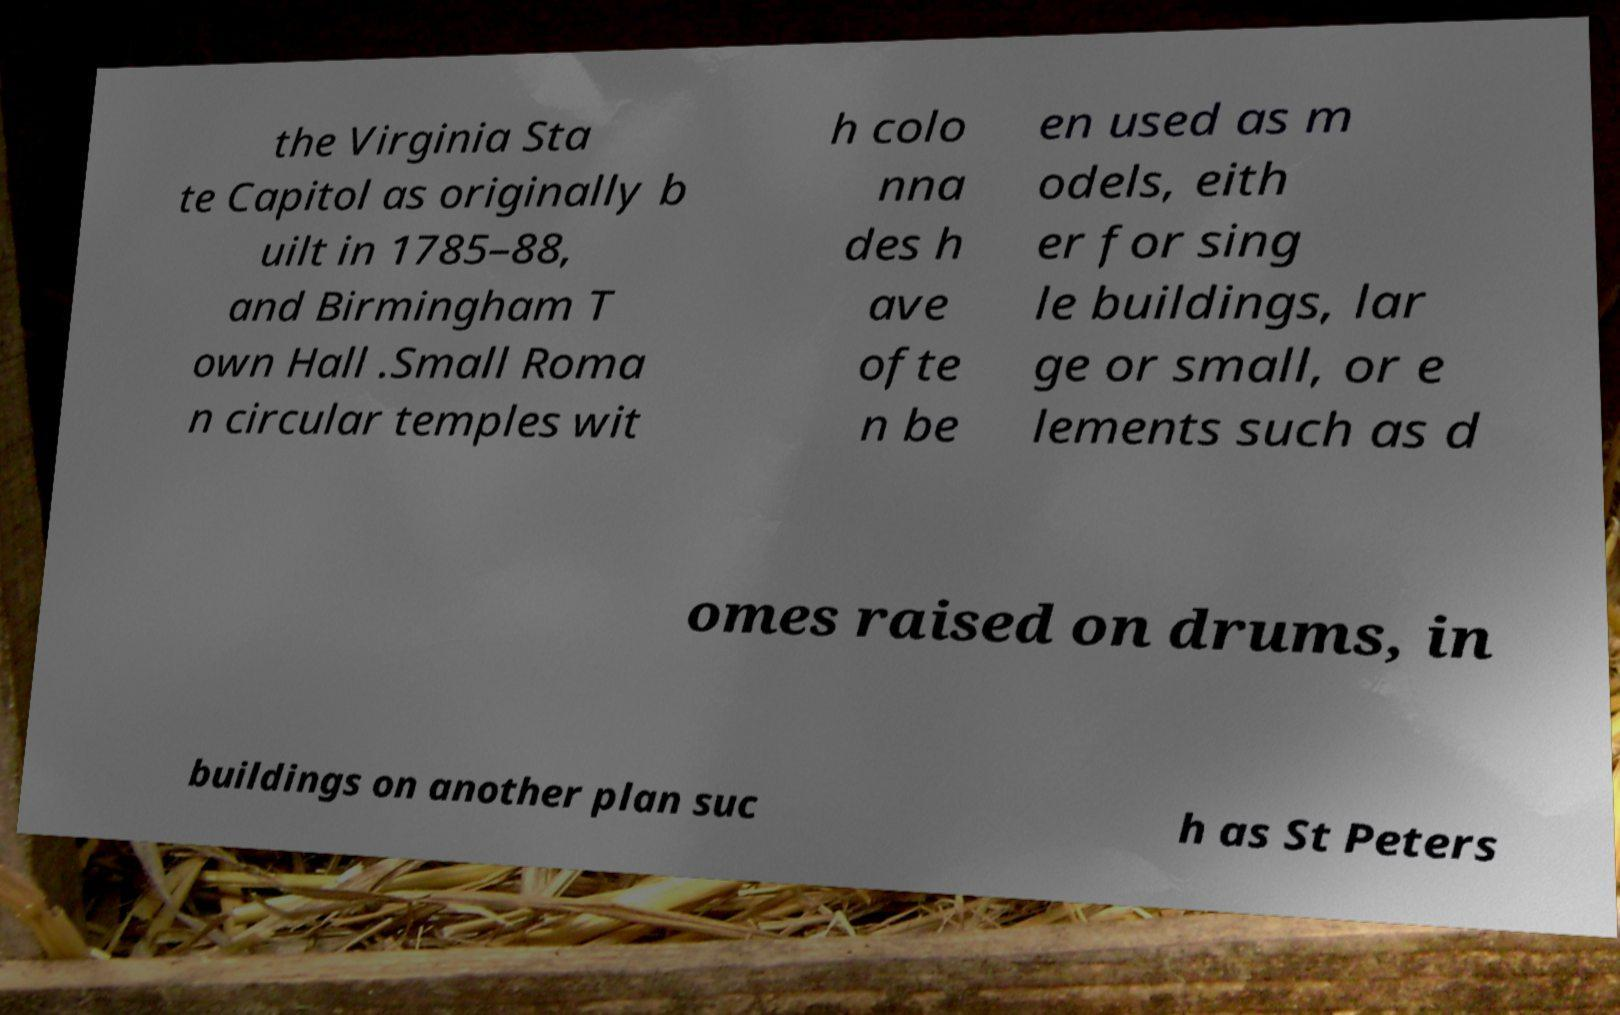For documentation purposes, I need the text within this image transcribed. Could you provide that? the Virginia Sta te Capitol as originally b uilt in 1785–88, and Birmingham T own Hall .Small Roma n circular temples wit h colo nna des h ave ofte n be en used as m odels, eith er for sing le buildings, lar ge or small, or e lements such as d omes raised on drums, in buildings on another plan suc h as St Peters 